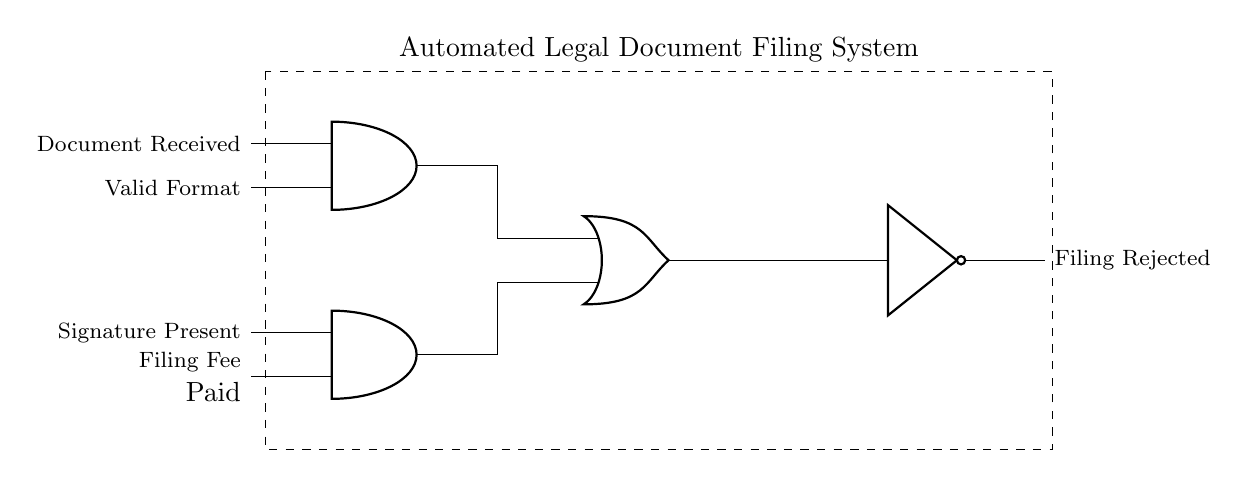What are the inputs for the first AND gate? The first AND gate has two inputs: "Document Received" and "Valid Format." These inputs are labeled on the left side of the gate in the circuit diagram.
Answer: Document Received, Valid Format How many inputs does the second AND gate have? The second AND gate also has two inputs, which are "Signature Present" and "Filing Fee Paid." These inputs are indicated on the left side of the second AND gate in the diagram.
Answer: 2 What does the output of the OR gate represent? The output of the OR gate represents the combined logic of the two AND gates. If either of those gates outputs true, indicating that either set of conditions is met, the OR gate will output true, leading to further processing.
Answer: Approved for filing What is the final output of the circuit? The final output of the circuit, represented at the output of the NOT gate, is "Filing Rejected." This indicates that if the conditions are not met (i.e., if the OR gate outputs false), the document filing will be rejected.
Answer: Filing Rejected How many logic gates are used in this circuit? The circuit utilizes four logic gates in total: two AND gates, one OR gate, and one NOT gate. Counting each of these components provides the answer.
Answer: 4 What condition leads to the filing fee being paid? The filing fee being paid is one of the inputs to the second AND gate. If this condition, along with the signature being present, is met, the AND gate will output true.
Answer: Signature Present, Filing Fee Paid 